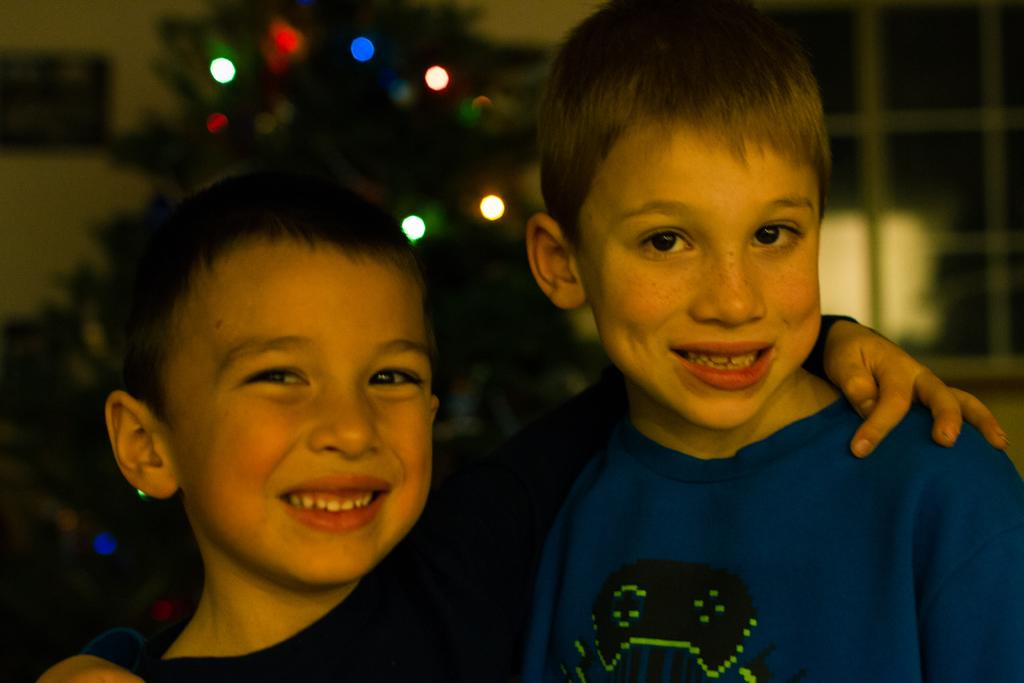How many boys are in the image? There are two boys in the image. What are the boys doing in the image? The boys are standing and smiling. What can be seen in the image besides the boys? There is a tree with decorative lights and buildings visible in the background of the image. What type of silk is being used to decorate the playground in the image? There is no playground or silk present in the image. 